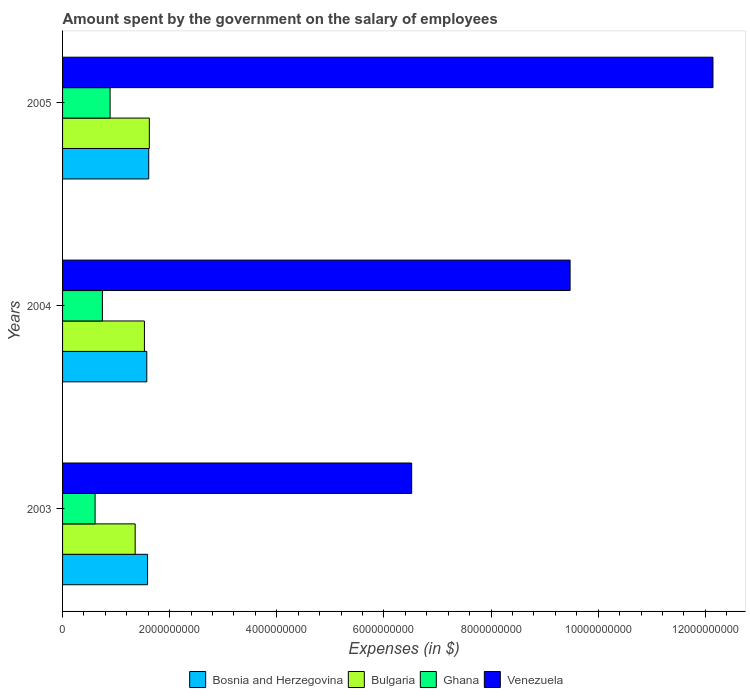How many different coloured bars are there?
Your answer should be very brief. 4. Are the number of bars per tick equal to the number of legend labels?
Keep it short and to the point. Yes. How many bars are there on the 1st tick from the bottom?
Your answer should be compact. 4. What is the amount spent on the salary of employees by the government in Ghana in 2004?
Provide a succinct answer. 7.44e+08. Across all years, what is the maximum amount spent on the salary of employees by the government in Ghana?
Offer a very short reply. 8.87e+08. Across all years, what is the minimum amount spent on the salary of employees by the government in Bulgaria?
Ensure brevity in your answer.  1.36e+09. In which year was the amount spent on the salary of employees by the government in Ghana maximum?
Your answer should be very brief. 2005. In which year was the amount spent on the salary of employees by the government in Bulgaria minimum?
Your answer should be very brief. 2003. What is the total amount spent on the salary of employees by the government in Bosnia and Herzegovina in the graph?
Keep it short and to the point. 4.77e+09. What is the difference between the amount spent on the salary of employees by the government in Bosnia and Herzegovina in 2004 and that in 2005?
Your answer should be compact. -3.61e+07. What is the difference between the amount spent on the salary of employees by the government in Bosnia and Herzegovina in 2005 and the amount spent on the salary of employees by the government in Ghana in 2003?
Your answer should be very brief. 1.00e+09. What is the average amount spent on the salary of employees by the government in Bosnia and Herzegovina per year?
Keep it short and to the point. 1.59e+09. In the year 2005, what is the difference between the amount spent on the salary of employees by the government in Bosnia and Herzegovina and amount spent on the salary of employees by the government in Venezuela?
Offer a very short reply. -1.05e+1. What is the ratio of the amount spent on the salary of employees by the government in Ghana in 2003 to that in 2004?
Make the answer very short. 0.82. Is the amount spent on the salary of employees by the government in Bosnia and Herzegovina in 2004 less than that in 2005?
Your answer should be compact. Yes. Is the difference between the amount spent on the salary of employees by the government in Bosnia and Herzegovina in 2003 and 2005 greater than the difference between the amount spent on the salary of employees by the government in Venezuela in 2003 and 2005?
Provide a succinct answer. Yes. What is the difference between the highest and the second highest amount spent on the salary of employees by the government in Venezuela?
Make the answer very short. 2.67e+09. What is the difference between the highest and the lowest amount spent on the salary of employees by the government in Ghana?
Your response must be concise. 2.80e+08. What does the 4th bar from the top in 2005 represents?
Make the answer very short. Bosnia and Herzegovina. What does the 2nd bar from the bottom in 2004 represents?
Ensure brevity in your answer.  Bulgaria. Is it the case that in every year, the sum of the amount spent on the salary of employees by the government in Ghana and amount spent on the salary of employees by the government in Bulgaria is greater than the amount spent on the salary of employees by the government in Bosnia and Herzegovina?
Offer a terse response. Yes. Are all the bars in the graph horizontal?
Provide a short and direct response. Yes. How many years are there in the graph?
Make the answer very short. 3. What is the difference between two consecutive major ticks on the X-axis?
Offer a terse response. 2.00e+09. Are the values on the major ticks of X-axis written in scientific E-notation?
Offer a terse response. No. Does the graph contain grids?
Provide a short and direct response. No. How are the legend labels stacked?
Give a very brief answer. Horizontal. What is the title of the graph?
Give a very brief answer. Amount spent by the government on the salary of employees. What is the label or title of the X-axis?
Your answer should be compact. Expenses (in $). What is the Expenses (in $) in Bosnia and Herzegovina in 2003?
Your answer should be compact. 1.59e+09. What is the Expenses (in $) of Bulgaria in 2003?
Offer a terse response. 1.36e+09. What is the Expenses (in $) in Ghana in 2003?
Give a very brief answer. 6.07e+08. What is the Expenses (in $) of Venezuela in 2003?
Your response must be concise. 6.52e+09. What is the Expenses (in $) in Bosnia and Herzegovina in 2004?
Keep it short and to the point. 1.57e+09. What is the Expenses (in $) of Bulgaria in 2004?
Your answer should be compact. 1.53e+09. What is the Expenses (in $) of Ghana in 2004?
Provide a succinct answer. 7.44e+08. What is the Expenses (in $) in Venezuela in 2004?
Your answer should be compact. 9.48e+09. What is the Expenses (in $) in Bosnia and Herzegovina in 2005?
Your answer should be compact. 1.61e+09. What is the Expenses (in $) in Bulgaria in 2005?
Offer a very short reply. 1.62e+09. What is the Expenses (in $) in Ghana in 2005?
Offer a very short reply. 8.87e+08. What is the Expenses (in $) of Venezuela in 2005?
Offer a terse response. 1.21e+1. Across all years, what is the maximum Expenses (in $) of Bosnia and Herzegovina?
Provide a succinct answer. 1.61e+09. Across all years, what is the maximum Expenses (in $) in Bulgaria?
Your answer should be very brief. 1.62e+09. Across all years, what is the maximum Expenses (in $) in Ghana?
Give a very brief answer. 8.87e+08. Across all years, what is the maximum Expenses (in $) of Venezuela?
Offer a terse response. 1.21e+1. Across all years, what is the minimum Expenses (in $) in Bosnia and Herzegovina?
Your response must be concise. 1.57e+09. Across all years, what is the minimum Expenses (in $) in Bulgaria?
Offer a very short reply. 1.36e+09. Across all years, what is the minimum Expenses (in $) of Ghana?
Provide a succinct answer. 6.07e+08. Across all years, what is the minimum Expenses (in $) of Venezuela?
Make the answer very short. 6.52e+09. What is the total Expenses (in $) of Bosnia and Herzegovina in the graph?
Make the answer very short. 4.77e+09. What is the total Expenses (in $) of Bulgaria in the graph?
Provide a succinct answer. 4.50e+09. What is the total Expenses (in $) of Ghana in the graph?
Keep it short and to the point. 2.24e+09. What is the total Expenses (in $) of Venezuela in the graph?
Your response must be concise. 2.81e+1. What is the difference between the Expenses (in $) in Bosnia and Herzegovina in 2003 and that in 2004?
Make the answer very short. 1.45e+07. What is the difference between the Expenses (in $) of Bulgaria in 2003 and that in 2004?
Offer a very short reply. -1.73e+08. What is the difference between the Expenses (in $) in Ghana in 2003 and that in 2004?
Provide a succinct answer. -1.37e+08. What is the difference between the Expenses (in $) of Venezuela in 2003 and that in 2004?
Give a very brief answer. -2.96e+09. What is the difference between the Expenses (in $) of Bosnia and Herzegovina in 2003 and that in 2005?
Ensure brevity in your answer.  -2.17e+07. What is the difference between the Expenses (in $) of Bulgaria in 2003 and that in 2005?
Keep it short and to the point. -2.65e+08. What is the difference between the Expenses (in $) of Ghana in 2003 and that in 2005?
Provide a short and direct response. -2.80e+08. What is the difference between the Expenses (in $) in Venezuela in 2003 and that in 2005?
Offer a very short reply. -5.63e+09. What is the difference between the Expenses (in $) of Bosnia and Herzegovina in 2004 and that in 2005?
Ensure brevity in your answer.  -3.61e+07. What is the difference between the Expenses (in $) in Bulgaria in 2004 and that in 2005?
Ensure brevity in your answer.  -9.17e+07. What is the difference between the Expenses (in $) of Ghana in 2004 and that in 2005?
Provide a short and direct response. -1.43e+08. What is the difference between the Expenses (in $) of Venezuela in 2004 and that in 2005?
Offer a very short reply. -2.67e+09. What is the difference between the Expenses (in $) of Bosnia and Herzegovina in 2003 and the Expenses (in $) of Bulgaria in 2004?
Offer a very short reply. 5.86e+07. What is the difference between the Expenses (in $) of Bosnia and Herzegovina in 2003 and the Expenses (in $) of Ghana in 2004?
Offer a terse response. 8.43e+08. What is the difference between the Expenses (in $) in Bosnia and Herzegovina in 2003 and the Expenses (in $) in Venezuela in 2004?
Provide a succinct answer. -7.89e+09. What is the difference between the Expenses (in $) of Bulgaria in 2003 and the Expenses (in $) of Ghana in 2004?
Provide a succinct answer. 6.11e+08. What is the difference between the Expenses (in $) in Bulgaria in 2003 and the Expenses (in $) in Venezuela in 2004?
Give a very brief answer. -8.12e+09. What is the difference between the Expenses (in $) in Ghana in 2003 and the Expenses (in $) in Venezuela in 2004?
Your response must be concise. -8.87e+09. What is the difference between the Expenses (in $) in Bosnia and Herzegovina in 2003 and the Expenses (in $) in Bulgaria in 2005?
Offer a terse response. -3.31e+07. What is the difference between the Expenses (in $) in Bosnia and Herzegovina in 2003 and the Expenses (in $) in Ghana in 2005?
Your response must be concise. 7.00e+08. What is the difference between the Expenses (in $) in Bosnia and Herzegovina in 2003 and the Expenses (in $) in Venezuela in 2005?
Your response must be concise. -1.06e+1. What is the difference between the Expenses (in $) in Bulgaria in 2003 and the Expenses (in $) in Ghana in 2005?
Ensure brevity in your answer.  4.68e+08. What is the difference between the Expenses (in $) in Bulgaria in 2003 and the Expenses (in $) in Venezuela in 2005?
Provide a succinct answer. -1.08e+1. What is the difference between the Expenses (in $) of Ghana in 2003 and the Expenses (in $) of Venezuela in 2005?
Provide a short and direct response. -1.15e+1. What is the difference between the Expenses (in $) of Bosnia and Herzegovina in 2004 and the Expenses (in $) of Bulgaria in 2005?
Ensure brevity in your answer.  -4.75e+07. What is the difference between the Expenses (in $) in Bosnia and Herzegovina in 2004 and the Expenses (in $) in Ghana in 2005?
Keep it short and to the point. 6.85e+08. What is the difference between the Expenses (in $) in Bosnia and Herzegovina in 2004 and the Expenses (in $) in Venezuela in 2005?
Give a very brief answer. -1.06e+1. What is the difference between the Expenses (in $) of Bulgaria in 2004 and the Expenses (in $) of Ghana in 2005?
Ensure brevity in your answer.  6.41e+08. What is the difference between the Expenses (in $) in Bulgaria in 2004 and the Expenses (in $) in Venezuela in 2005?
Make the answer very short. -1.06e+1. What is the difference between the Expenses (in $) of Ghana in 2004 and the Expenses (in $) of Venezuela in 2005?
Your answer should be very brief. -1.14e+1. What is the average Expenses (in $) in Bosnia and Herzegovina per year?
Offer a terse response. 1.59e+09. What is the average Expenses (in $) of Bulgaria per year?
Your answer should be very brief. 1.50e+09. What is the average Expenses (in $) of Ghana per year?
Keep it short and to the point. 7.46e+08. What is the average Expenses (in $) in Venezuela per year?
Provide a short and direct response. 9.38e+09. In the year 2003, what is the difference between the Expenses (in $) in Bosnia and Herzegovina and Expenses (in $) in Bulgaria?
Keep it short and to the point. 2.31e+08. In the year 2003, what is the difference between the Expenses (in $) of Bosnia and Herzegovina and Expenses (in $) of Ghana?
Your response must be concise. 9.80e+08. In the year 2003, what is the difference between the Expenses (in $) of Bosnia and Herzegovina and Expenses (in $) of Venezuela?
Offer a very short reply. -4.93e+09. In the year 2003, what is the difference between the Expenses (in $) of Bulgaria and Expenses (in $) of Ghana?
Provide a succinct answer. 7.48e+08. In the year 2003, what is the difference between the Expenses (in $) in Bulgaria and Expenses (in $) in Venezuela?
Your response must be concise. -5.16e+09. In the year 2003, what is the difference between the Expenses (in $) of Ghana and Expenses (in $) of Venezuela?
Provide a succinct answer. -5.91e+09. In the year 2004, what is the difference between the Expenses (in $) in Bosnia and Herzegovina and Expenses (in $) in Bulgaria?
Your answer should be very brief. 4.42e+07. In the year 2004, what is the difference between the Expenses (in $) of Bosnia and Herzegovina and Expenses (in $) of Ghana?
Your response must be concise. 8.28e+08. In the year 2004, what is the difference between the Expenses (in $) of Bosnia and Herzegovina and Expenses (in $) of Venezuela?
Your response must be concise. -7.90e+09. In the year 2004, what is the difference between the Expenses (in $) of Bulgaria and Expenses (in $) of Ghana?
Offer a terse response. 7.84e+08. In the year 2004, what is the difference between the Expenses (in $) in Bulgaria and Expenses (in $) in Venezuela?
Give a very brief answer. -7.95e+09. In the year 2004, what is the difference between the Expenses (in $) of Ghana and Expenses (in $) of Venezuela?
Keep it short and to the point. -8.73e+09. In the year 2005, what is the difference between the Expenses (in $) in Bosnia and Herzegovina and Expenses (in $) in Bulgaria?
Ensure brevity in your answer.  -1.14e+07. In the year 2005, what is the difference between the Expenses (in $) of Bosnia and Herzegovina and Expenses (in $) of Ghana?
Ensure brevity in your answer.  7.21e+08. In the year 2005, what is the difference between the Expenses (in $) of Bosnia and Herzegovina and Expenses (in $) of Venezuela?
Ensure brevity in your answer.  -1.05e+1. In the year 2005, what is the difference between the Expenses (in $) in Bulgaria and Expenses (in $) in Ghana?
Provide a succinct answer. 7.33e+08. In the year 2005, what is the difference between the Expenses (in $) in Bulgaria and Expenses (in $) in Venezuela?
Make the answer very short. -1.05e+1. In the year 2005, what is the difference between the Expenses (in $) of Ghana and Expenses (in $) of Venezuela?
Provide a succinct answer. -1.13e+1. What is the ratio of the Expenses (in $) of Bosnia and Herzegovina in 2003 to that in 2004?
Offer a very short reply. 1.01. What is the ratio of the Expenses (in $) of Bulgaria in 2003 to that in 2004?
Your answer should be very brief. 0.89. What is the ratio of the Expenses (in $) in Ghana in 2003 to that in 2004?
Provide a succinct answer. 0.82. What is the ratio of the Expenses (in $) of Venezuela in 2003 to that in 2004?
Provide a short and direct response. 0.69. What is the ratio of the Expenses (in $) in Bosnia and Herzegovina in 2003 to that in 2005?
Offer a very short reply. 0.99. What is the ratio of the Expenses (in $) of Bulgaria in 2003 to that in 2005?
Provide a short and direct response. 0.84. What is the ratio of the Expenses (in $) in Ghana in 2003 to that in 2005?
Offer a terse response. 0.68. What is the ratio of the Expenses (in $) in Venezuela in 2003 to that in 2005?
Provide a succinct answer. 0.54. What is the ratio of the Expenses (in $) in Bosnia and Herzegovina in 2004 to that in 2005?
Your answer should be very brief. 0.98. What is the ratio of the Expenses (in $) in Bulgaria in 2004 to that in 2005?
Provide a short and direct response. 0.94. What is the ratio of the Expenses (in $) in Ghana in 2004 to that in 2005?
Give a very brief answer. 0.84. What is the ratio of the Expenses (in $) in Venezuela in 2004 to that in 2005?
Your response must be concise. 0.78. What is the difference between the highest and the second highest Expenses (in $) of Bosnia and Herzegovina?
Offer a very short reply. 2.17e+07. What is the difference between the highest and the second highest Expenses (in $) in Bulgaria?
Provide a short and direct response. 9.17e+07. What is the difference between the highest and the second highest Expenses (in $) in Ghana?
Your response must be concise. 1.43e+08. What is the difference between the highest and the second highest Expenses (in $) of Venezuela?
Give a very brief answer. 2.67e+09. What is the difference between the highest and the lowest Expenses (in $) in Bosnia and Herzegovina?
Your answer should be very brief. 3.61e+07. What is the difference between the highest and the lowest Expenses (in $) in Bulgaria?
Offer a terse response. 2.65e+08. What is the difference between the highest and the lowest Expenses (in $) of Ghana?
Your answer should be very brief. 2.80e+08. What is the difference between the highest and the lowest Expenses (in $) of Venezuela?
Keep it short and to the point. 5.63e+09. 